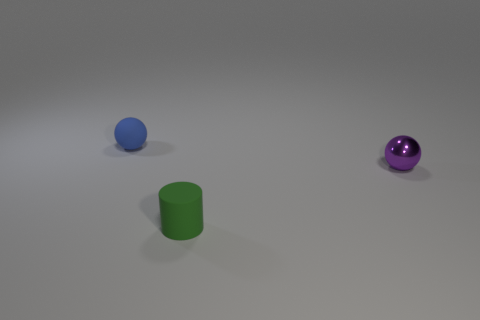Are there any tiny green cylinders that are in front of the tiny ball to the right of the sphere that is behind the small purple metal sphere?
Your answer should be very brief. Yes. There is a blue rubber object that is the same size as the metal ball; what is its shape?
Keep it short and to the point. Sphere. There is another small object that is the same shape as the blue matte thing; what is its color?
Ensure brevity in your answer.  Purple. How many objects are either tiny green cylinders or small spheres?
Offer a terse response. 3. Does the object behind the tiny metal ball have the same shape as the purple object that is to the right of the tiny rubber cylinder?
Provide a short and direct response. Yes. The small matte thing that is in front of the small shiny thing has what shape?
Give a very brief answer. Cylinder. Is the number of purple objects that are in front of the green object the same as the number of purple metal spheres that are to the right of the small purple metal sphere?
Your answer should be very brief. Yes. How many objects are big red matte cylinders or spheres on the left side of the green object?
Ensure brevity in your answer.  1. There is a object that is both in front of the blue rubber sphere and to the left of the purple shiny thing; what is its shape?
Ensure brevity in your answer.  Cylinder. What is the small ball in front of the ball that is to the left of the purple metallic thing made of?
Your answer should be compact. Metal. 